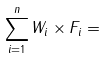Convert formula to latex. <formula><loc_0><loc_0><loc_500><loc_500>\sum _ { i = 1 } ^ { n } W _ { i } \times F _ { i } =</formula> 